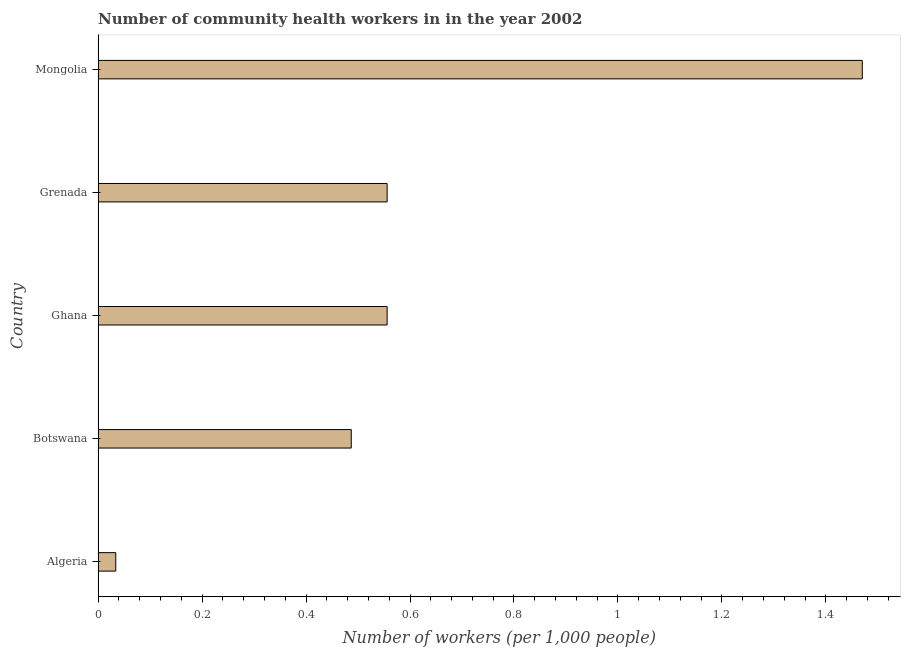Does the graph contain any zero values?
Ensure brevity in your answer.  No. Does the graph contain grids?
Provide a short and direct response. No. What is the title of the graph?
Provide a short and direct response. Number of community health workers in in the year 2002. What is the label or title of the X-axis?
Make the answer very short. Number of workers (per 1,0 people). What is the label or title of the Y-axis?
Ensure brevity in your answer.  Country. What is the number of community health workers in Botswana?
Your answer should be compact. 0.49. Across all countries, what is the maximum number of community health workers?
Your answer should be compact. 1.47. Across all countries, what is the minimum number of community health workers?
Provide a succinct answer. 0.03. In which country was the number of community health workers maximum?
Ensure brevity in your answer.  Mongolia. In which country was the number of community health workers minimum?
Your answer should be compact. Algeria. What is the sum of the number of community health workers?
Provide a succinct answer. 3.1. What is the difference between the number of community health workers in Algeria and Grenada?
Keep it short and to the point. -0.52. What is the average number of community health workers per country?
Keep it short and to the point. 0.62. What is the median number of community health workers?
Offer a terse response. 0.56. In how many countries, is the number of community health workers greater than 0.84 ?
Keep it short and to the point. 1. What is the ratio of the number of community health workers in Botswana to that in Mongolia?
Offer a very short reply. 0.33. What is the difference between the highest and the second highest number of community health workers?
Provide a succinct answer. 0.91. What is the difference between the highest and the lowest number of community health workers?
Ensure brevity in your answer.  1.44. Are all the bars in the graph horizontal?
Your response must be concise. Yes. How many countries are there in the graph?
Give a very brief answer. 5. What is the difference between two consecutive major ticks on the X-axis?
Ensure brevity in your answer.  0.2. What is the Number of workers (per 1,000 people) of Algeria?
Provide a succinct answer. 0.03. What is the Number of workers (per 1,000 people) of Botswana?
Keep it short and to the point. 0.49. What is the Number of workers (per 1,000 people) of Ghana?
Give a very brief answer. 0.56. What is the Number of workers (per 1,000 people) in Grenada?
Give a very brief answer. 0.56. What is the Number of workers (per 1,000 people) of Mongolia?
Provide a short and direct response. 1.47. What is the difference between the Number of workers (per 1,000 people) in Algeria and Botswana?
Offer a terse response. -0.45. What is the difference between the Number of workers (per 1,000 people) in Algeria and Ghana?
Provide a short and direct response. -0.52. What is the difference between the Number of workers (per 1,000 people) in Algeria and Grenada?
Provide a succinct answer. -0.52. What is the difference between the Number of workers (per 1,000 people) in Algeria and Mongolia?
Keep it short and to the point. -1.44. What is the difference between the Number of workers (per 1,000 people) in Botswana and Ghana?
Ensure brevity in your answer.  -0.07. What is the difference between the Number of workers (per 1,000 people) in Botswana and Grenada?
Your response must be concise. -0.07. What is the difference between the Number of workers (per 1,000 people) in Botswana and Mongolia?
Your answer should be very brief. -0.98. What is the difference between the Number of workers (per 1,000 people) in Ghana and Mongolia?
Provide a short and direct response. -0.91. What is the difference between the Number of workers (per 1,000 people) in Grenada and Mongolia?
Provide a short and direct response. -0.91. What is the ratio of the Number of workers (per 1,000 people) in Algeria to that in Botswana?
Make the answer very short. 0.07. What is the ratio of the Number of workers (per 1,000 people) in Algeria to that in Ghana?
Your response must be concise. 0.06. What is the ratio of the Number of workers (per 1,000 people) in Algeria to that in Grenada?
Ensure brevity in your answer.  0.06. What is the ratio of the Number of workers (per 1,000 people) in Algeria to that in Mongolia?
Give a very brief answer. 0.02. What is the ratio of the Number of workers (per 1,000 people) in Botswana to that in Ghana?
Your response must be concise. 0.88. What is the ratio of the Number of workers (per 1,000 people) in Botswana to that in Grenada?
Make the answer very short. 0.88. What is the ratio of the Number of workers (per 1,000 people) in Botswana to that in Mongolia?
Your response must be concise. 0.33. What is the ratio of the Number of workers (per 1,000 people) in Ghana to that in Mongolia?
Your answer should be very brief. 0.38. What is the ratio of the Number of workers (per 1,000 people) in Grenada to that in Mongolia?
Keep it short and to the point. 0.38. 